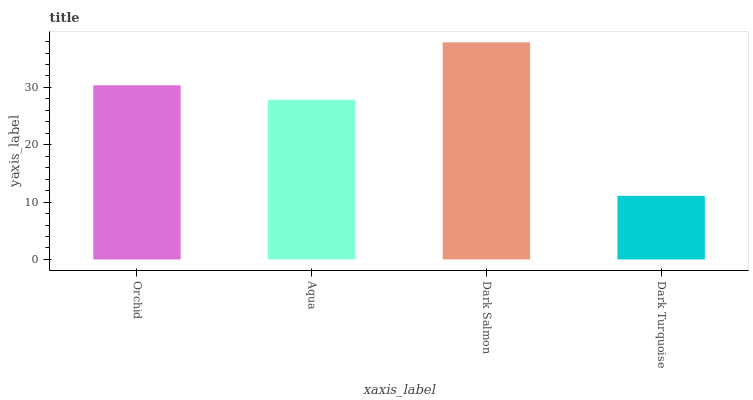Is Dark Turquoise the minimum?
Answer yes or no. Yes. Is Dark Salmon the maximum?
Answer yes or no. Yes. Is Aqua the minimum?
Answer yes or no. No. Is Aqua the maximum?
Answer yes or no. No. Is Orchid greater than Aqua?
Answer yes or no. Yes. Is Aqua less than Orchid?
Answer yes or no. Yes. Is Aqua greater than Orchid?
Answer yes or no. No. Is Orchid less than Aqua?
Answer yes or no. No. Is Orchid the high median?
Answer yes or no. Yes. Is Aqua the low median?
Answer yes or no. Yes. Is Dark Turquoise the high median?
Answer yes or no. No. Is Dark Turquoise the low median?
Answer yes or no. No. 